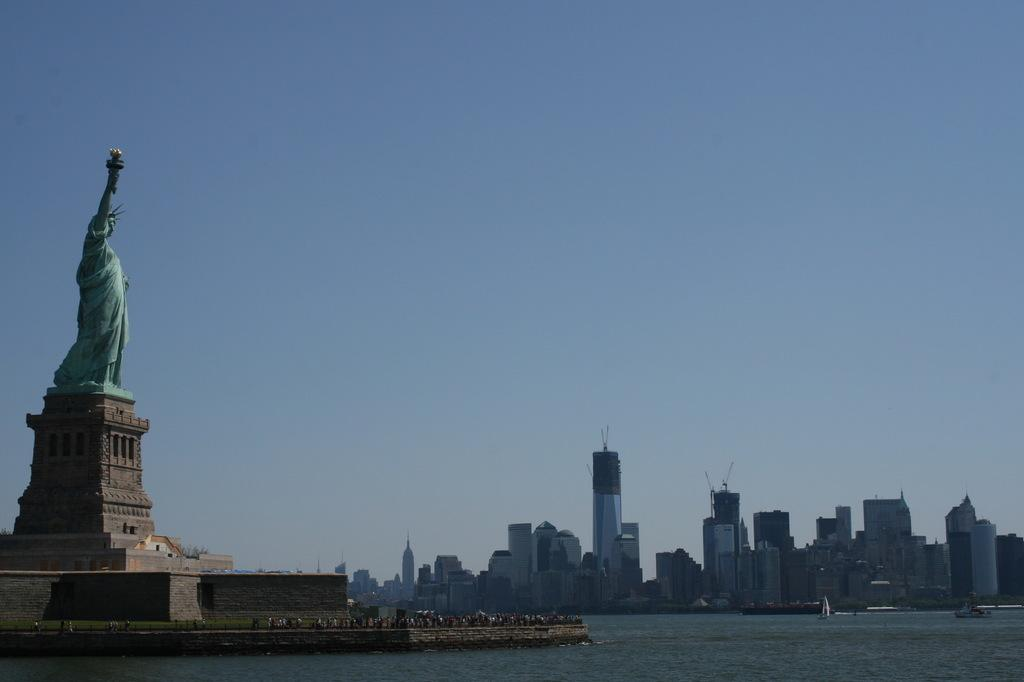What is located on the left side of the image? There is a statue on the left side of the image. What can be seen on the right side of the image? There is sea visible on the right side of the image. What type of structures are in the background of the image? There are buildings in the background of the image. What is visible in the sky in the image? The sky is visible in the image. Can you tell me how many trucks are parked near the statue in the image? There is no truck present in the image; it features a statue and sea. Are there any babies or sisters visible in the image? There is no baby or sister depicted in the image. 